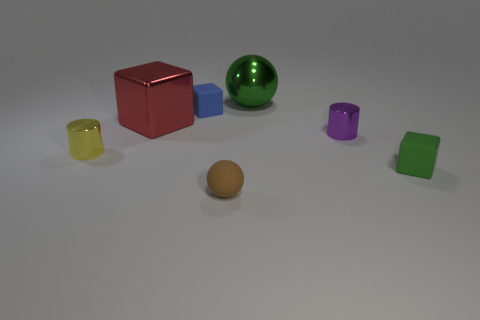Subtract 1 blocks. How many blocks are left? 2 Add 1 large brown matte cylinders. How many objects exist? 8 Subtract all cylinders. How many objects are left? 5 Subtract 1 red blocks. How many objects are left? 6 Subtract all small yellow metallic cylinders. Subtract all small metallic cylinders. How many objects are left? 4 Add 1 brown matte spheres. How many brown matte spheres are left? 2 Add 5 small brown matte objects. How many small brown matte objects exist? 6 